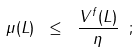<formula> <loc_0><loc_0><loc_500><loc_500>\mu ( L ) \ \leq \ \frac { V ^ { f } ( L ) } { \eta } \ ;</formula> 